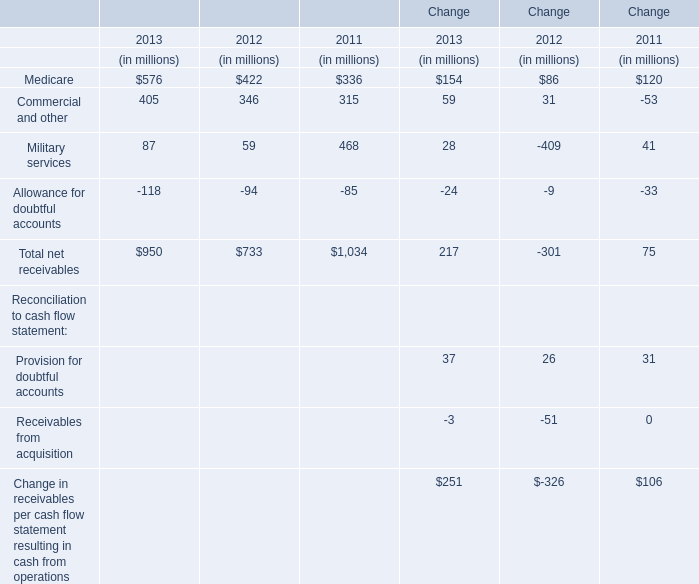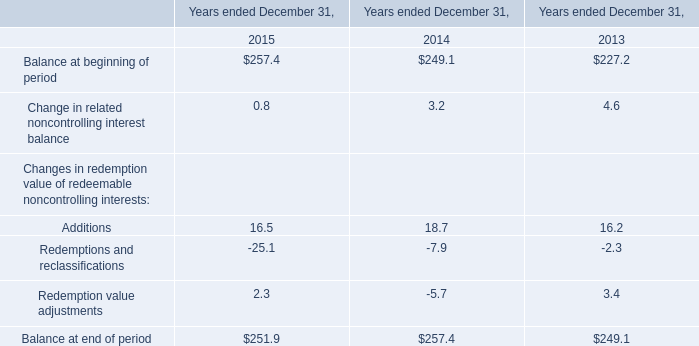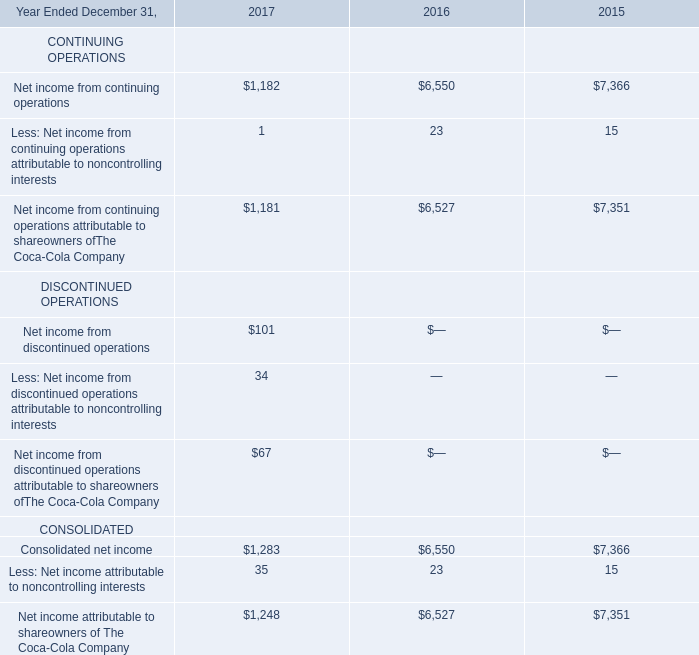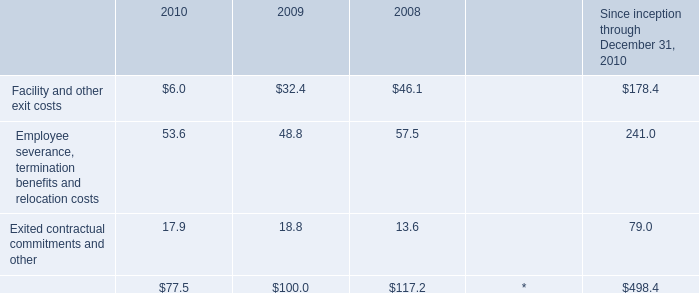What is the sum of Military services in 2012 and Employee severance, termination benefits and relocation costs in 2009? (in million) 
Computations: (59 + 48.8)
Answer: 107.8. 